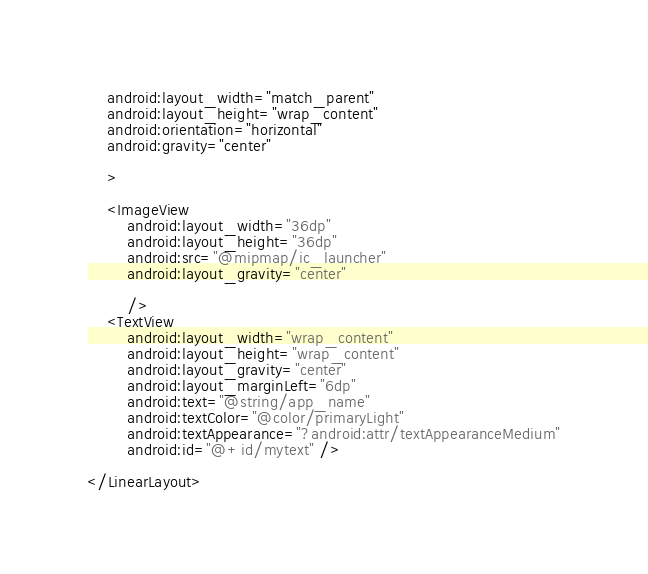Convert code to text. <code><loc_0><loc_0><loc_500><loc_500><_XML_>    android:layout_width="match_parent"
    android:layout_height="wrap_content"
    android:orientation="horizontal"
    android:gravity="center"

    >

    <ImageView
        android:layout_width="36dp"
        android:layout_height="36dp"
        android:src="@mipmap/ic_launcher"
        android:layout_gravity="center"

        />
    <TextView
        android:layout_width="wrap_content"
        android:layout_height="wrap_content"
        android:layout_gravity="center"
        android:layout_marginLeft="6dp"
        android:text="@string/app_name"
        android:textColor="@color/primaryLight"
        android:textAppearance="?android:attr/textAppearanceMedium"
        android:id="@+id/mytext" />

</LinearLayout></code> 